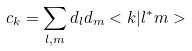Convert formula to latex. <formula><loc_0><loc_0><loc_500><loc_500>c _ { k } = \sum _ { l , m } d _ { l } d _ { m } < k | l ^ { * } m ></formula> 